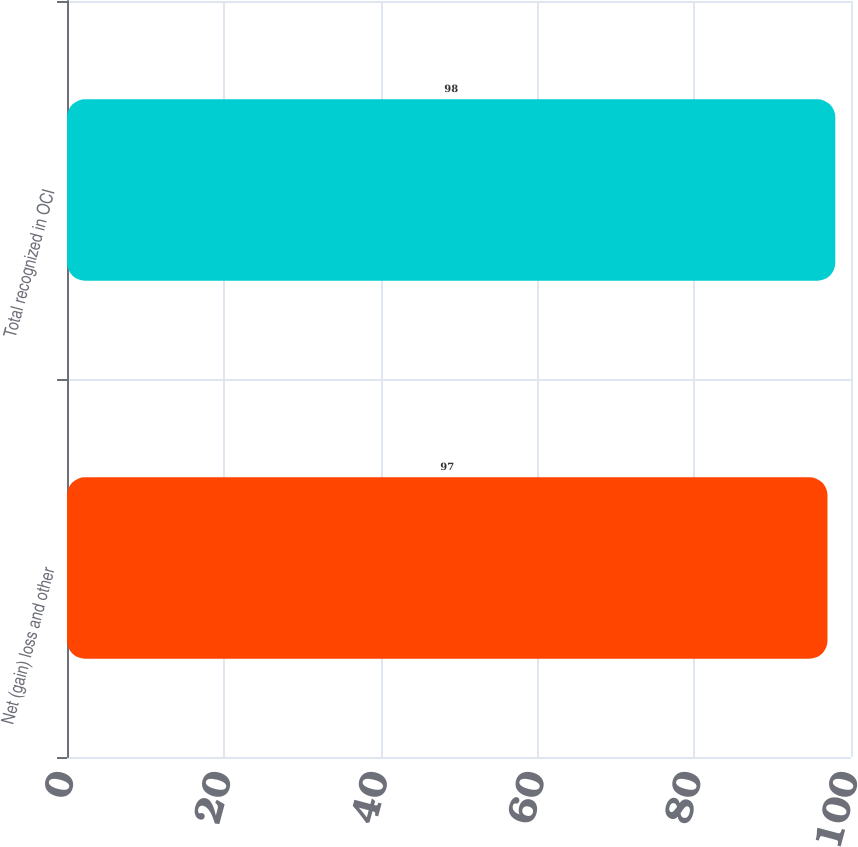Convert chart to OTSL. <chart><loc_0><loc_0><loc_500><loc_500><bar_chart><fcel>Net (gain) loss and other<fcel>Total recognized in OCI<nl><fcel>97<fcel>98<nl></chart> 